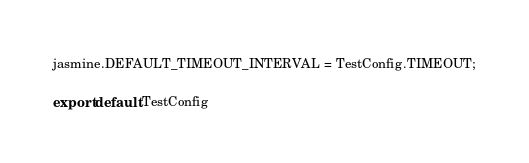<code> <loc_0><loc_0><loc_500><loc_500><_JavaScript_>jasmine.DEFAULT_TIMEOUT_INTERVAL = TestConfig.TIMEOUT;

export default TestConfig</code> 